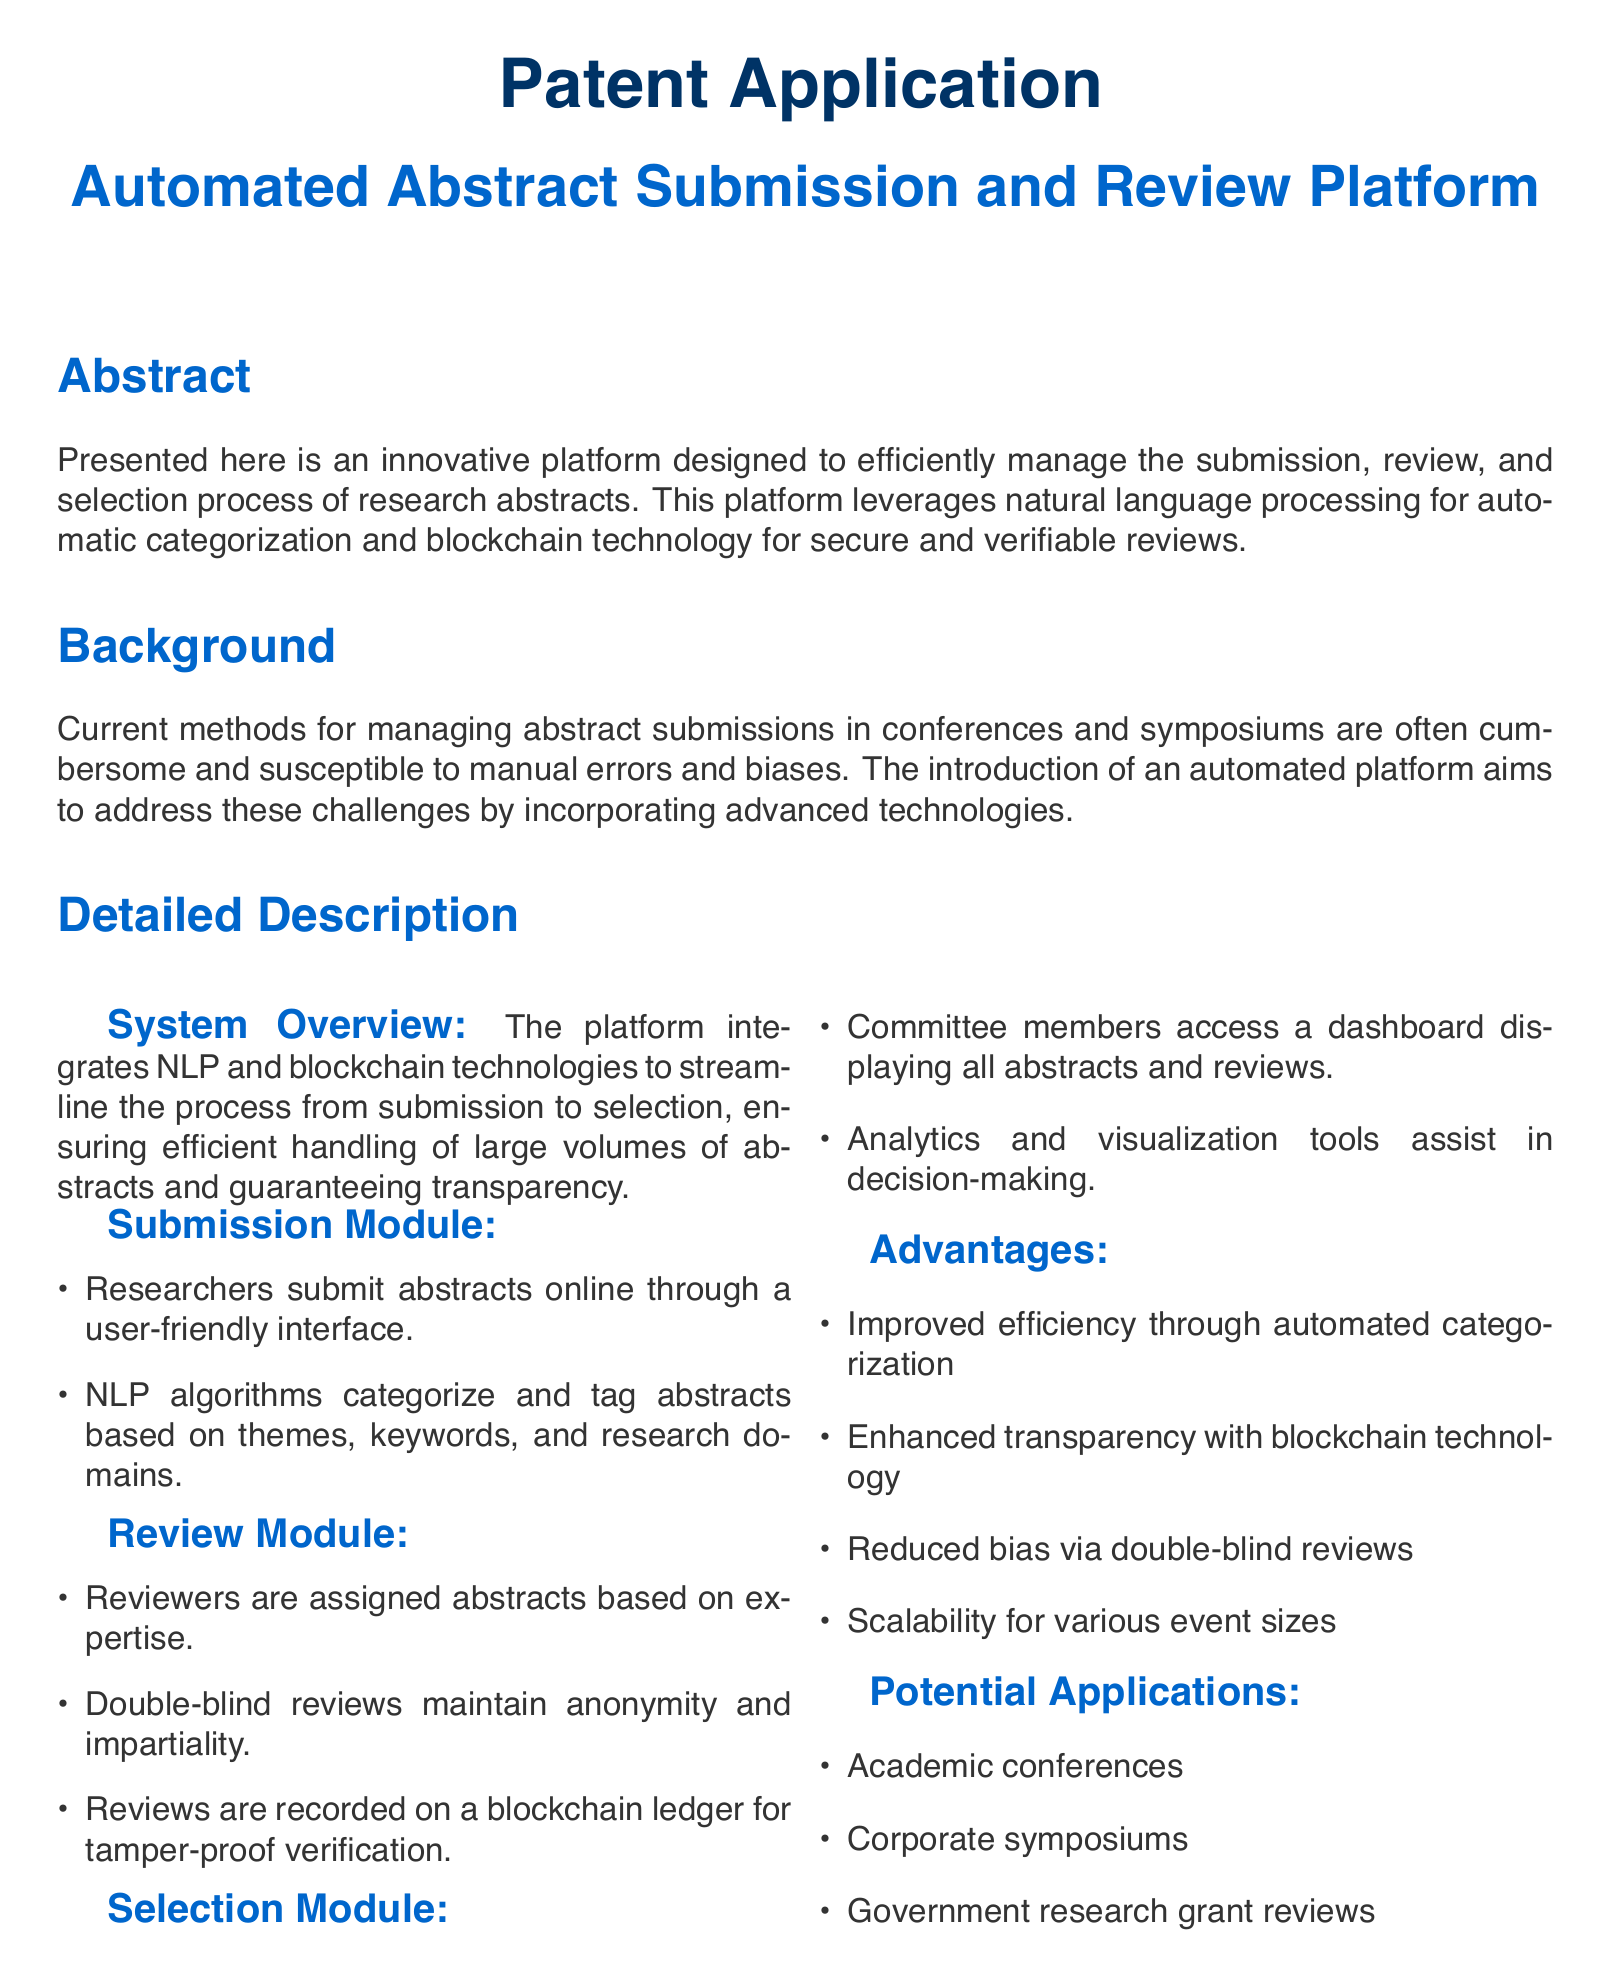What is the title of the platform? The title of the platform is explicitly mentioned in the document as part of the main heading.
Answer: Automated Abstract Submission and Review Platform What technology is used for submission categorization? The document states that NLP algorithms are used for categorization in the submission module.
Answer: Natural language processing What feature ensures anonymity in reviews? The document describes the double-blind review process as a way to maintain anonymity and impartiality.
Answer: Double-blind reviews How are reviews verified? The document mentions that reviews are recorded on a blockchain ledger for verification purposes.
Answer: Blockchain ledger What is one advantage of the platform? The advantages of the platform are listed, highlighting improved efficiency, transparency, reduced bias, and scalability.
Answer: Improved efficiency through automated categorization List one potential application of the platform. The document lists potential applications for the platform, which include academic conferences, corporate symposiums, and government research grant reviews.
Answer: Academic conferences How is the submission process described? The document states that researchers submit abstracts online through a user-friendly interface as part of the submission module.
Answer: User-friendly interface What does the selection module provide to committee members? The selection module is described in a way that indicates it provides a dashboard along with analytics and visualization tools to assist in decision-making.
Answer: Dashboard displaying all abstracts and reviews 